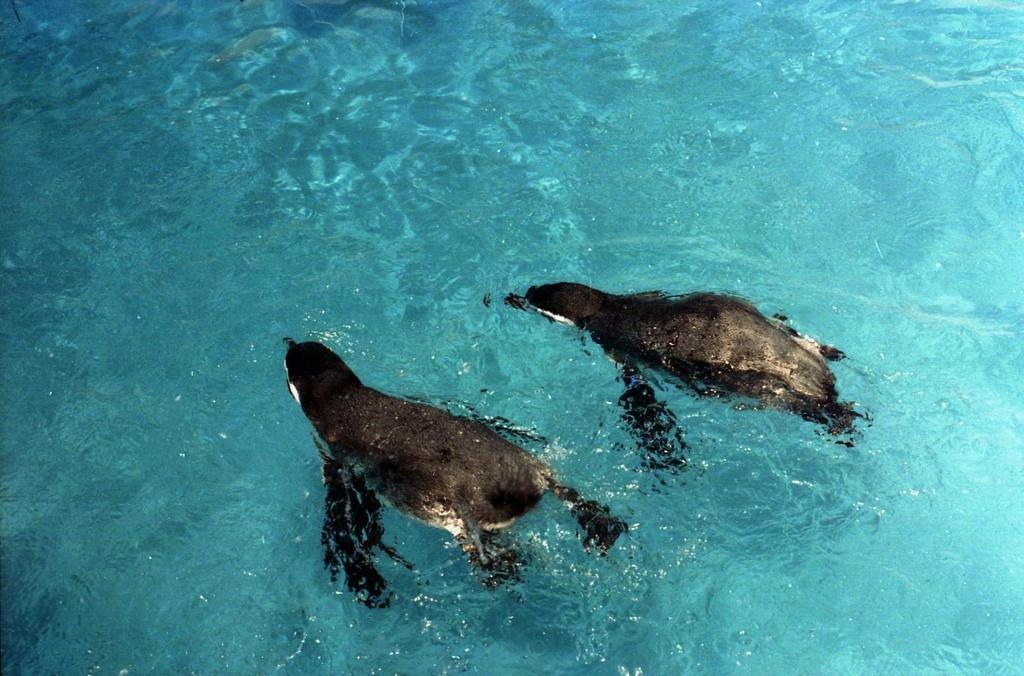What animals are present in the image? There are two whales in the image. Where are the whales located? The whales are in the water. What type of desk can be seen in the image? There is no desk present in the image; it features two whales in the water. How many times does the calendar appear in the image? There is no calendar present in the image. 